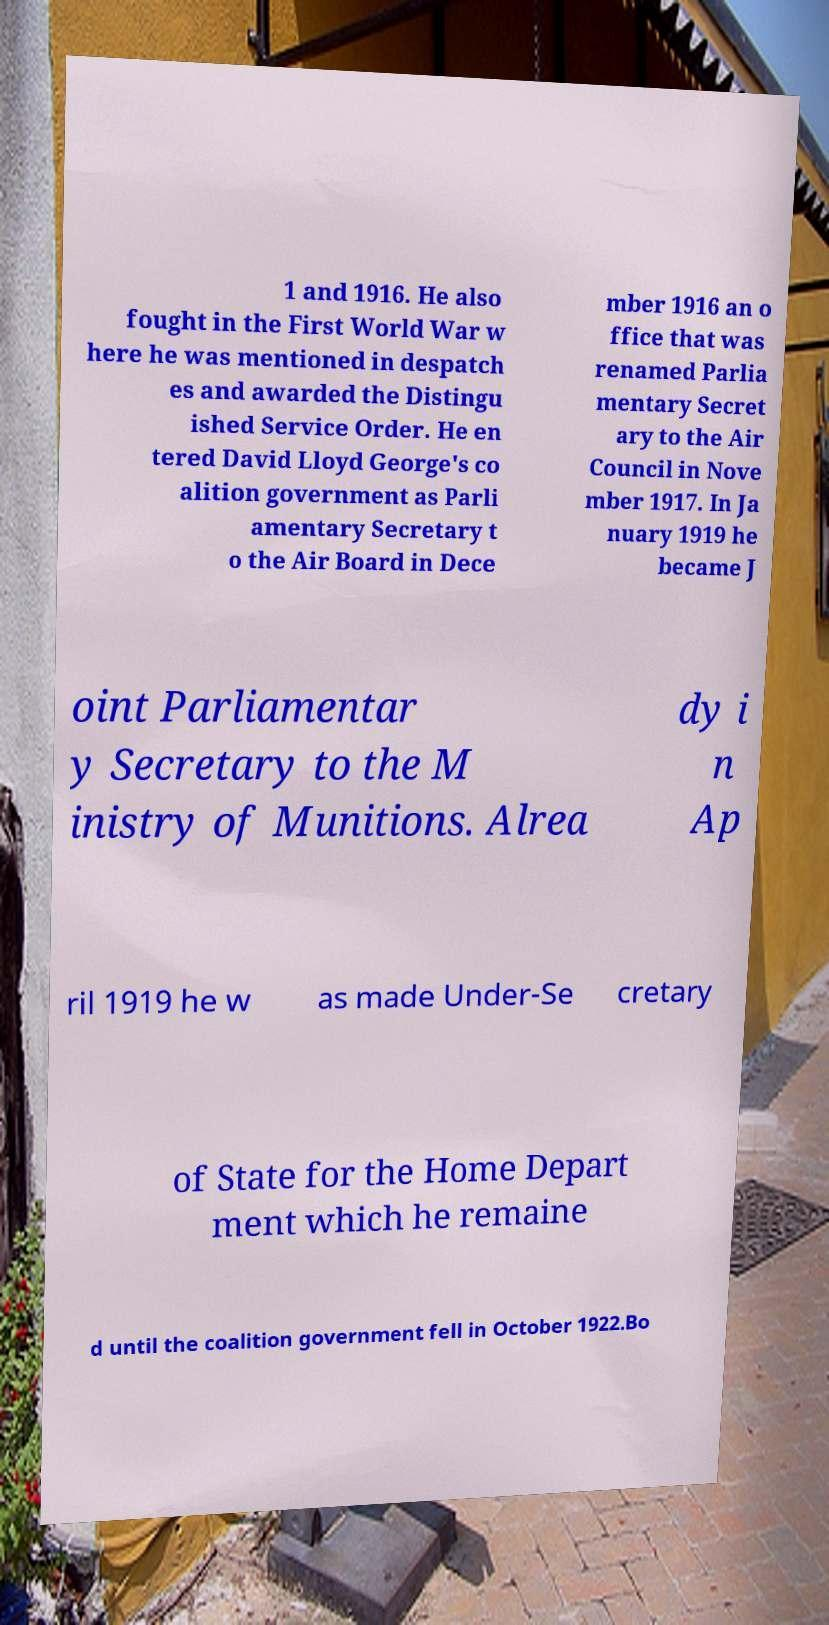I need the written content from this picture converted into text. Can you do that? 1 and 1916. He also fought in the First World War w here he was mentioned in despatch es and awarded the Distingu ished Service Order. He en tered David Lloyd George's co alition government as Parli amentary Secretary t o the Air Board in Dece mber 1916 an o ffice that was renamed Parlia mentary Secret ary to the Air Council in Nove mber 1917. In Ja nuary 1919 he became J oint Parliamentar y Secretary to the M inistry of Munitions. Alrea dy i n Ap ril 1919 he w as made Under-Se cretary of State for the Home Depart ment which he remaine d until the coalition government fell in October 1922.Bo 